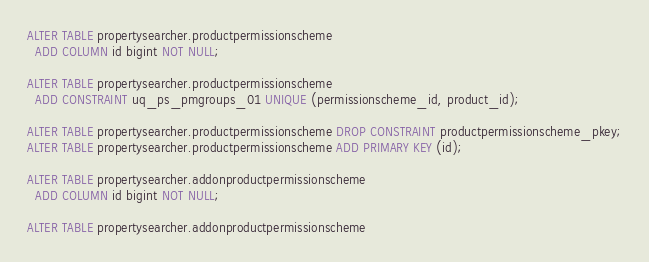<code> <loc_0><loc_0><loc_500><loc_500><_SQL_>
ALTER TABLE propertysearcher.productpermissionscheme
  ADD COLUMN id bigint NOT NULL;

ALTER TABLE propertysearcher.productpermissionscheme
  ADD CONSTRAINT uq_ps_pmgroups_01 UNIQUE (permissionscheme_id, product_id);

ALTER TABLE propertysearcher.productpermissionscheme DROP CONSTRAINT productpermissionscheme_pkey;
ALTER TABLE propertysearcher.productpermissionscheme ADD PRIMARY KEY (id);

ALTER TABLE propertysearcher.addonproductpermissionscheme
  ADD COLUMN id bigint NOT NULL;

ALTER TABLE propertysearcher.addonproductpermissionscheme</code> 